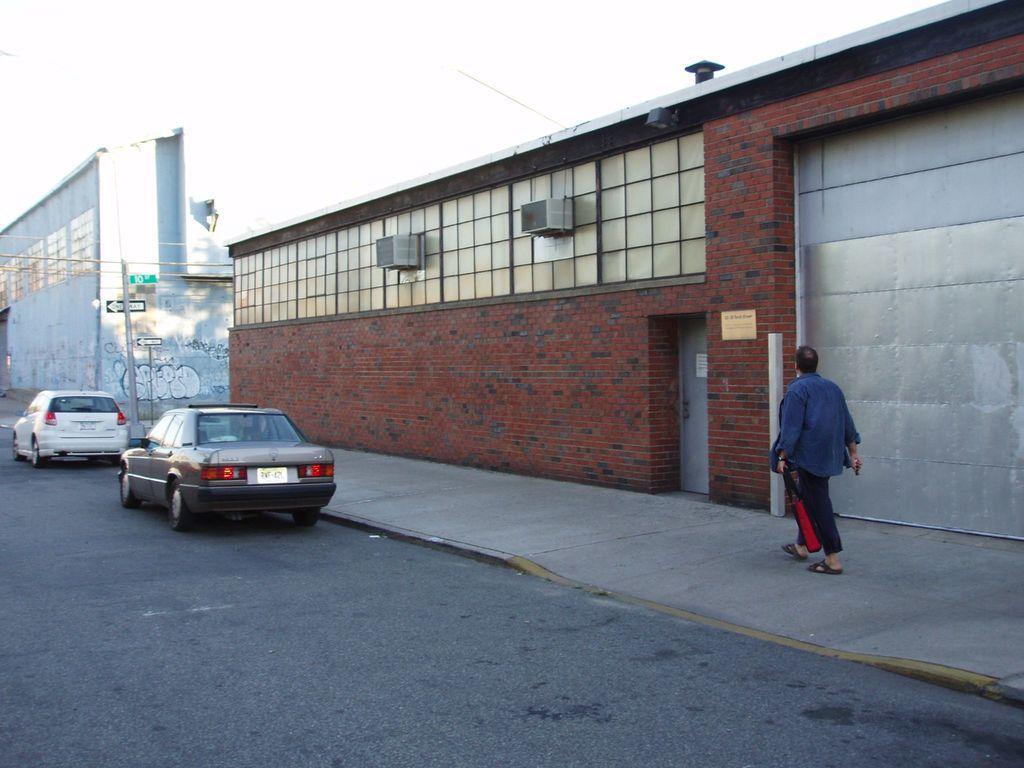Please provide a concise description of this image. This is the picture of a road. In this picture there is a person walking on the footpath and there are poles on the footpath. At the back there are buildings. At the top there is sky. At the bottom there is a road. 